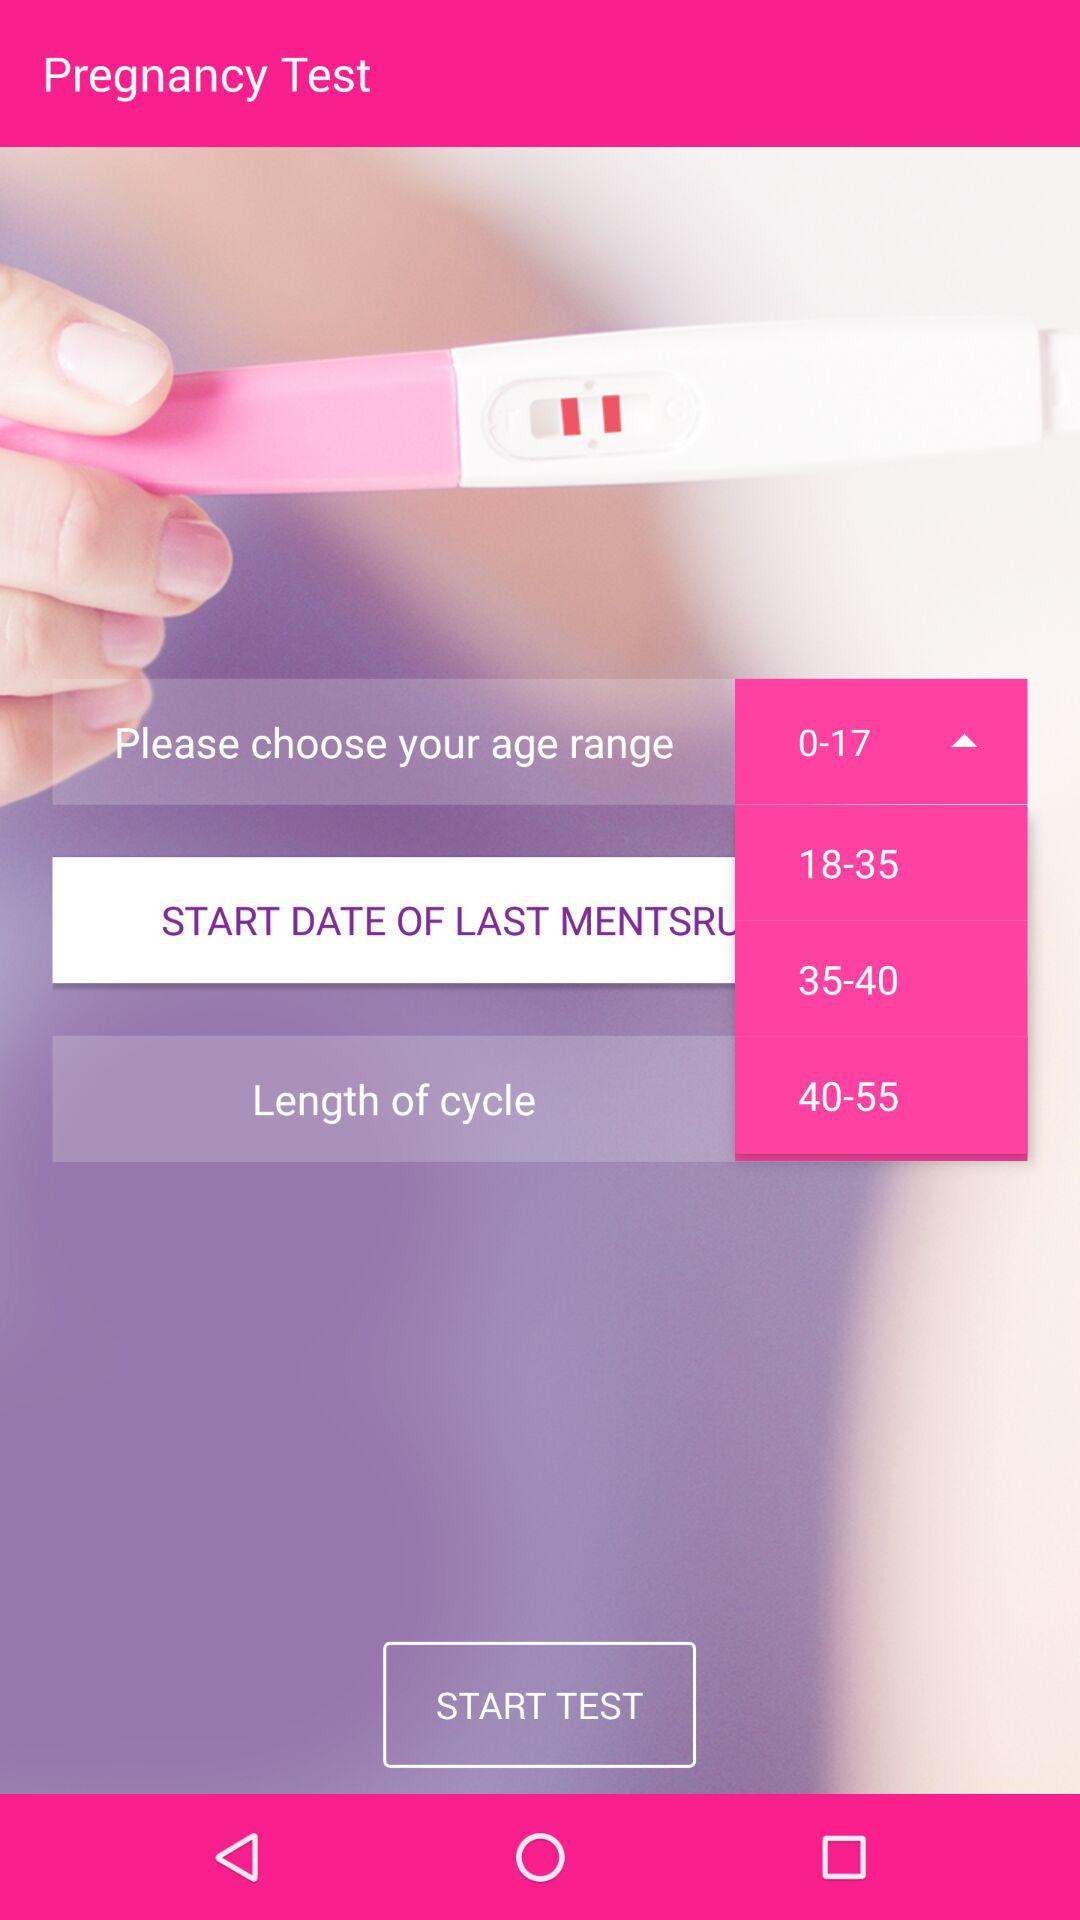How many age ranges are there?
Answer the question using a single word or phrase. 4 